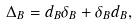<formula> <loc_0><loc_0><loc_500><loc_500>\Delta _ { B } = d _ { B } \delta _ { B } + \delta _ { B } d _ { B } ,</formula> 